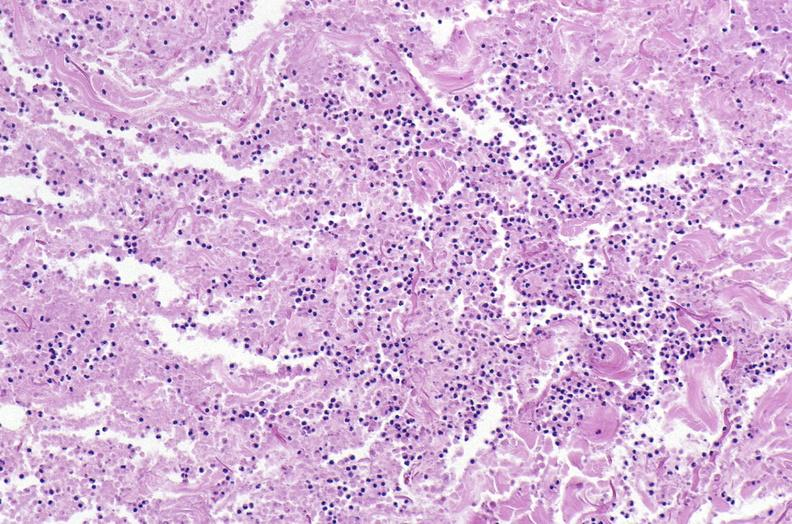where is this?
Answer the question using a single word or phrase. Skin 